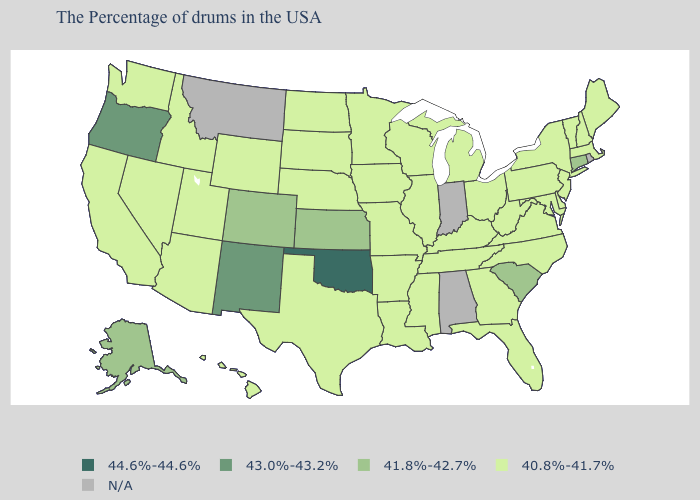Does Alaska have the highest value in the West?
Concise answer only. No. Which states have the lowest value in the USA?
Answer briefly. Maine, Massachusetts, New Hampshire, Vermont, New York, New Jersey, Delaware, Maryland, Pennsylvania, Virginia, North Carolina, West Virginia, Ohio, Florida, Georgia, Michigan, Kentucky, Tennessee, Wisconsin, Illinois, Mississippi, Louisiana, Missouri, Arkansas, Minnesota, Iowa, Nebraska, Texas, South Dakota, North Dakota, Wyoming, Utah, Arizona, Idaho, Nevada, California, Washington, Hawaii. What is the highest value in the USA?
Quick response, please. 44.6%-44.6%. Does the first symbol in the legend represent the smallest category?
Concise answer only. No. Does New Jersey have the lowest value in the USA?
Give a very brief answer. Yes. What is the highest value in states that border Ohio?
Quick response, please. 40.8%-41.7%. What is the value of New Hampshire?
Give a very brief answer. 40.8%-41.7%. What is the value of New Jersey?
Write a very short answer. 40.8%-41.7%. Is the legend a continuous bar?
Be succinct. No. Which states have the highest value in the USA?
Concise answer only. Oklahoma. Which states hav the highest value in the West?
Be succinct. New Mexico, Oregon. What is the value of Colorado?
Give a very brief answer. 41.8%-42.7%. What is the highest value in the MidWest ?
Quick response, please. 41.8%-42.7%. What is the highest value in the USA?
Quick response, please. 44.6%-44.6%. What is the value of Washington?
Concise answer only. 40.8%-41.7%. 